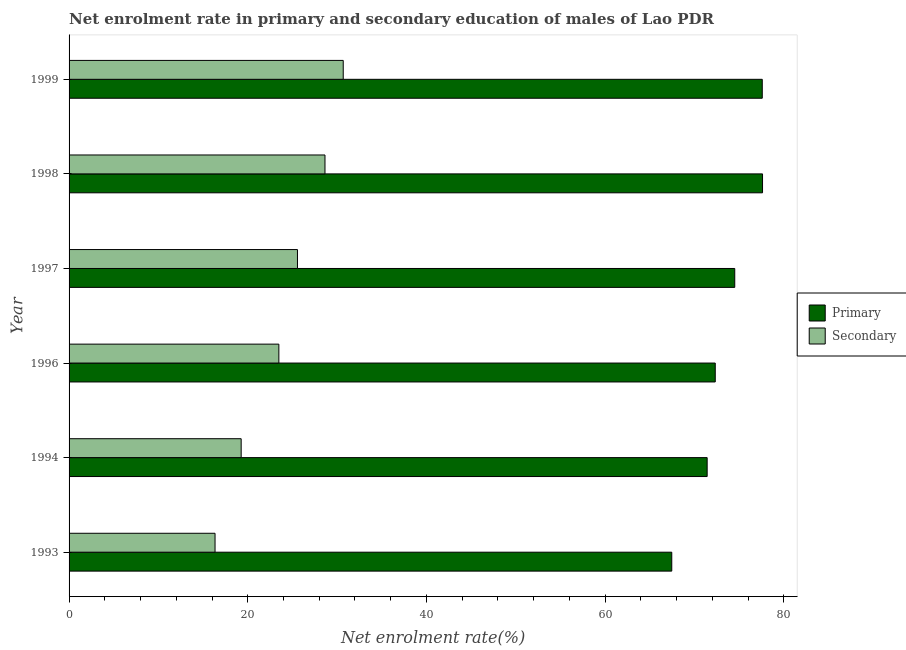Are the number of bars on each tick of the Y-axis equal?
Ensure brevity in your answer.  Yes. How many bars are there on the 3rd tick from the top?
Keep it short and to the point. 2. How many bars are there on the 5th tick from the bottom?
Your response must be concise. 2. What is the label of the 1st group of bars from the top?
Provide a succinct answer. 1999. In how many cases, is the number of bars for a given year not equal to the number of legend labels?
Your response must be concise. 0. What is the enrollment rate in secondary education in 1996?
Make the answer very short. 23.48. Across all years, what is the maximum enrollment rate in secondary education?
Provide a short and direct response. 30.68. Across all years, what is the minimum enrollment rate in primary education?
Keep it short and to the point. 67.45. In which year was the enrollment rate in primary education maximum?
Offer a terse response. 1998. What is the total enrollment rate in primary education in the graph?
Keep it short and to the point. 440.88. What is the difference between the enrollment rate in secondary education in 1998 and that in 1999?
Your response must be concise. -2.04. What is the difference between the enrollment rate in secondary education in 1994 and the enrollment rate in primary education in 1997?
Offer a terse response. -55.24. What is the average enrollment rate in primary education per year?
Your response must be concise. 73.48. In the year 1993, what is the difference between the enrollment rate in secondary education and enrollment rate in primary education?
Your response must be concise. -51.12. In how many years, is the enrollment rate in primary education greater than 52 %?
Provide a short and direct response. 6. What is the ratio of the enrollment rate in secondary education in 1993 to that in 1999?
Make the answer very short. 0.53. Is the enrollment rate in primary education in 1993 less than that in 1998?
Offer a very short reply. Yes. What is the difference between the highest and the second highest enrollment rate in secondary education?
Provide a short and direct response. 2.04. What is the difference between the highest and the lowest enrollment rate in primary education?
Your response must be concise. 10.16. In how many years, is the enrollment rate in secondary education greater than the average enrollment rate in secondary education taken over all years?
Make the answer very short. 3. What does the 1st bar from the top in 1999 represents?
Make the answer very short. Secondary. What does the 2nd bar from the bottom in 1997 represents?
Your answer should be very brief. Secondary. How many years are there in the graph?
Keep it short and to the point. 6. What is the difference between two consecutive major ticks on the X-axis?
Provide a succinct answer. 20. Are the values on the major ticks of X-axis written in scientific E-notation?
Provide a short and direct response. No. Does the graph contain any zero values?
Offer a very short reply. No. Where does the legend appear in the graph?
Provide a succinct answer. Center right. How many legend labels are there?
Your response must be concise. 2. How are the legend labels stacked?
Keep it short and to the point. Vertical. What is the title of the graph?
Offer a terse response. Net enrolment rate in primary and secondary education of males of Lao PDR. What is the label or title of the X-axis?
Your answer should be compact. Net enrolment rate(%). What is the label or title of the Y-axis?
Your answer should be compact. Year. What is the Net enrolment rate(%) of Primary in 1993?
Make the answer very short. 67.45. What is the Net enrolment rate(%) of Secondary in 1993?
Your answer should be very brief. 16.34. What is the Net enrolment rate(%) of Primary in 1994?
Give a very brief answer. 71.41. What is the Net enrolment rate(%) of Secondary in 1994?
Offer a terse response. 19.26. What is the Net enrolment rate(%) of Primary in 1996?
Your answer should be very brief. 72.32. What is the Net enrolment rate(%) in Secondary in 1996?
Provide a short and direct response. 23.48. What is the Net enrolment rate(%) of Primary in 1997?
Keep it short and to the point. 74.5. What is the Net enrolment rate(%) in Secondary in 1997?
Provide a short and direct response. 25.56. What is the Net enrolment rate(%) of Primary in 1998?
Provide a succinct answer. 77.61. What is the Net enrolment rate(%) of Secondary in 1998?
Your answer should be very brief. 28.64. What is the Net enrolment rate(%) in Primary in 1999?
Provide a succinct answer. 77.58. What is the Net enrolment rate(%) of Secondary in 1999?
Offer a very short reply. 30.68. Across all years, what is the maximum Net enrolment rate(%) in Primary?
Make the answer very short. 77.61. Across all years, what is the maximum Net enrolment rate(%) of Secondary?
Offer a very short reply. 30.68. Across all years, what is the minimum Net enrolment rate(%) in Primary?
Give a very brief answer. 67.45. Across all years, what is the minimum Net enrolment rate(%) in Secondary?
Keep it short and to the point. 16.34. What is the total Net enrolment rate(%) of Primary in the graph?
Keep it short and to the point. 440.88. What is the total Net enrolment rate(%) in Secondary in the graph?
Give a very brief answer. 143.97. What is the difference between the Net enrolment rate(%) of Primary in 1993 and that in 1994?
Keep it short and to the point. -3.96. What is the difference between the Net enrolment rate(%) of Secondary in 1993 and that in 1994?
Provide a short and direct response. -2.92. What is the difference between the Net enrolment rate(%) of Primary in 1993 and that in 1996?
Keep it short and to the point. -4.87. What is the difference between the Net enrolment rate(%) in Secondary in 1993 and that in 1996?
Make the answer very short. -7.14. What is the difference between the Net enrolment rate(%) in Primary in 1993 and that in 1997?
Your response must be concise. -7.05. What is the difference between the Net enrolment rate(%) in Secondary in 1993 and that in 1997?
Your response must be concise. -9.22. What is the difference between the Net enrolment rate(%) in Primary in 1993 and that in 1998?
Ensure brevity in your answer.  -10.16. What is the difference between the Net enrolment rate(%) in Secondary in 1993 and that in 1998?
Your answer should be compact. -12.31. What is the difference between the Net enrolment rate(%) of Primary in 1993 and that in 1999?
Ensure brevity in your answer.  -10.13. What is the difference between the Net enrolment rate(%) of Secondary in 1993 and that in 1999?
Offer a terse response. -14.35. What is the difference between the Net enrolment rate(%) in Primary in 1994 and that in 1996?
Make the answer very short. -0.91. What is the difference between the Net enrolment rate(%) in Secondary in 1994 and that in 1996?
Provide a succinct answer. -4.22. What is the difference between the Net enrolment rate(%) in Primary in 1994 and that in 1997?
Provide a succinct answer. -3.09. What is the difference between the Net enrolment rate(%) of Secondary in 1994 and that in 1997?
Your answer should be very brief. -6.3. What is the difference between the Net enrolment rate(%) of Primary in 1994 and that in 1998?
Provide a succinct answer. -6.2. What is the difference between the Net enrolment rate(%) in Secondary in 1994 and that in 1998?
Offer a terse response. -9.38. What is the difference between the Net enrolment rate(%) of Primary in 1994 and that in 1999?
Provide a succinct answer. -6.17. What is the difference between the Net enrolment rate(%) of Secondary in 1994 and that in 1999?
Give a very brief answer. -11.42. What is the difference between the Net enrolment rate(%) in Primary in 1996 and that in 1997?
Your answer should be very brief. -2.18. What is the difference between the Net enrolment rate(%) of Secondary in 1996 and that in 1997?
Keep it short and to the point. -2.08. What is the difference between the Net enrolment rate(%) in Primary in 1996 and that in 1998?
Provide a succinct answer. -5.29. What is the difference between the Net enrolment rate(%) in Secondary in 1996 and that in 1998?
Your answer should be compact. -5.16. What is the difference between the Net enrolment rate(%) in Primary in 1996 and that in 1999?
Your answer should be very brief. -5.26. What is the difference between the Net enrolment rate(%) of Secondary in 1996 and that in 1999?
Offer a terse response. -7.2. What is the difference between the Net enrolment rate(%) of Primary in 1997 and that in 1998?
Give a very brief answer. -3.11. What is the difference between the Net enrolment rate(%) of Secondary in 1997 and that in 1998?
Your answer should be very brief. -3.08. What is the difference between the Net enrolment rate(%) in Primary in 1997 and that in 1999?
Provide a short and direct response. -3.08. What is the difference between the Net enrolment rate(%) of Secondary in 1997 and that in 1999?
Your answer should be compact. -5.12. What is the difference between the Net enrolment rate(%) in Primary in 1998 and that in 1999?
Your response must be concise. 0.03. What is the difference between the Net enrolment rate(%) in Secondary in 1998 and that in 1999?
Your answer should be very brief. -2.04. What is the difference between the Net enrolment rate(%) in Primary in 1993 and the Net enrolment rate(%) in Secondary in 1994?
Provide a short and direct response. 48.19. What is the difference between the Net enrolment rate(%) of Primary in 1993 and the Net enrolment rate(%) of Secondary in 1996?
Provide a short and direct response. 43.97. What is the difference between the Net enrolment rate(%) of Primary in 1993 and the Net enrolment rate(%) of Secondary in 1997?
Your answer should be compact. 41.89. What is the difference between the Net enrolment rate(%) of Primary in 1993 and the Net enrolment rate(%) of Secondary in 1998?
Your response must be concise. 38.81. What is the difference between the Net enrolment rate(%) in Primary in 1993 and the Net enrolment rate(%) in Secondary in 1999?
Keep it short and to the point. 36.77. What is the difference between the Net enrolment rate(%) of Primary in 1994 and the Net enrolment rate(%) of Secondary in 1996?
Keep it short and to the point. 47.93. What is the difference between the Net enrolment rate(%) of Primary in 1994 and the Net enrolment rate(%) of Secondary in 1997?
Make the answer very short. 45.85. What is the difference between the Net enrolment rate(%) of Primary in 1994 and the Net enrolment rate(%) of Secondary in 1998?
Your answer should be very brief. 42.77. What is the difference between the Net enrolment rate(%) in Primary in 1994 and the Net enrolment rate(%) in Secondary in 1999?
Your answer should be very brief. 40.73. What is the difference between the Net enrolment rate(%) of Primary in 1996 and the Net enrolment rate(%) of Secondary in 1997?
Give a very brief answer. 46.76. What is the difference between the Net enrolment rate(%) in Primary in 1996 and the Net enrolment rate(%) in Secondary in 1998?
Make the answer very short. 43.68. What is the difference between the Net enrolment rate(%) in Primary in 1996 and the Net enrolment rate(%) in Secondary in 1999?
Your response must be concise. 41.64. What is the difference between the Net enrolment rate(%) of Primary in 1997 and the Net enrolment rate(%) of Secondary in 1998?
Your answer should be compact. 45.86. What is the difference between the Net enrolment rate(%) in Primary in 1997 and the Net enrolment rate(%) in Secondary in 1999?
Make the answer very short. 43.82. What is the difference between the Net enrolment rate(%) in Primary in 1998 and the Net enrolment rate(%) in Secondary in 1999?
Offer a terse response. 46.93. What is the average Net enrolment rate(%) in Primary per year?
Ensure brevity in your answer.  73.48. What is the average Net enrolment rate(%) of Secondary per year?
Offer a terse response. 23.99. In the year 1993, what is the difference between the Net enrolment rate(%) in Primary and Net enrolment rate(%) in Secondary?
Make the answer very short. 51.12. In the year 1994, what is the difference between the Net enrolment rate(%) of Primary and Net enrolment rate(%) of Secondary?
Give a very brief answer. 52.15. In the year 1996, what is the difference between the Net enrolment rate(%) in Primary and Net enrolment rate(%) in Secondary?
Your answer should be very brief. 48.84. In the year 1997, what is the difference between the Net enrolment rate(%) in Primary and Net enrolment rate(%) in Secondary?
Offer a very short reply. 48.94. In the year 1998, what is the difference between the Net enrolment rate(%) of Primary and Net enrolment rate(%) of Secondary?
Offer a terse response. 48.97. In the year 1999, what is the difference between the Net enrolment rate(%) in Primary and Net enrolment rate(%) in Secondary?
Your answer should be compact. 46.9. What is the ratio of the Net enrolment rate(%) of Primary in 1993 to that in 1994?
Give a very brief answer. 0.94. What is the ratio of the Net enrolment rate(%) of Secondary in 1993 to that in 1994?
Make the answer very short. 0.85. What is the ratio of the Net enrolment rate(%) in Primary in 1993 to that in 1996?
Ensure brevity in your answer.  0.93. What is the ratio of the Net enrolment rate(%) of Secondary in 1993 to that in 1996?
Your response must be concise. 0.7. What is the ratio of the Net enrolment rate(%) of Primary in 1993 to that in 1997?
Make the answer very short. 0.91. What is the ratio of the Net enrolment rate(%) in Secondary in 1993 to that in 1997?
Offer a terse response. 0.64. What is the ratio of the Net enrolment rate(%) of Primary in 1993 to that in 1998?
Your answer should be very brief. 0.87. What is the ratio of the Net enrolment rate(%) in Secondary in 1993 to that in 1998?
Give a very brief answer. 0.57. What is the ratio of the Net enrolment rate(%) of Primary in 1993 to that in 1999?
Your answer should be compact. 0.87. What is the ratio of the Net enrolment rate(%) in Secondary in 1993 to that in 1999?
Your answer should be compact. 0.53. What is the ratio of the Net enrolment rate(%) of Primary in 1994 to that in 1996?
Your response must be concise. 0.99. What is the ratio of the Net enrolment rate(%) of Secondary in 1994 to that in 1996?
Give a very brief answer. 0.82. What is the ratio of the Net enrolment rate(%) in Primary in 1994 to that in 1997?
Provide a succinct answer. 0.96. What is the ratio of the Net enrolment rate(%) of Secondary in 1994 to that in 1997?
Offer a very short reply. 0.75. What is the ratio of the Net enrolment rate(%) in Primary in 1994 to that in 1998?
Make the answer very short. 0.92. What is the ratio of the Net enrolment rate(%) in Secondary in 1994 to that in 1998?
Make the answer very short. 0.67. What is the ratio of the Net enrolment rate(%) in Primary in 1994 to that in 1999?
Make the answer very short. 0.92. What is the ratio of the Net enrolment rate(%) in Secondary in 1994 to that in 1999?
Your answer should be very brief. 0.63. What is the ratio of the Net enrolment rate(%) in Primary in 1996 to that in 1997?
Provide a short and direct response. 0.97. What is the ratio of the Net enrolment rate(%) of Secondary in 1996 to that in 1997?
Your answer should be compact. 0.92. What is the ratio of the Net enrolment rate(%) of Primary in 1996 to that in 1998?
Offer a terse response. 0.93. What is the ratio of the Net enrolment rate(%) in Secondary in 1996 to that in 1998?
Keep it short and to the point. 0.82. What is the ratio of the Net enrolment rate(%) in Primary in 1996 to that in 1999?
Give a very brief answer. 0.93. What is the ratio of the Net enrolment rate(%) in Secondary in 1996 to that in 1999?
Provide a succinct answer. 0.77. What is the ratio of the Net enrolment rate(%) in Primary in 1997 to that in 1998?
Ensure brevity in your answer.  0.96. What is the ratio of the Net enrolment rate(%) in Secondary in 1997 to that in 1998?
Your response must be concise. 0.89. What is the ratio of the Net enrolment rate(%) of Primary in 1997 to that in 1999?
Give a very brief answer. 0.96. What is the ratio of the Net enrolment rate(%) in Secondary in 1997 to that in 1999?
Your answer should be compact. 0.83. What is the ratio of the Net enrolment rate(%) in Secondary in 1998 to that in 1999?
Your answer should be compact. 0.93. What is the difference between the highest and the second highest Net enrolment rate(%) in Primary?
Provide a short and direct response. 0.03. What is the difference between the highest and the second highest Net enrolment rate(%) in Secondary?
Keep it short and to the point. 2.04. What is the difference between the highest and the lowest Net enrolment rate(%) of Primary?
Give a very brief answer. 10.16. What is the difference between the highest and the lowest Net enrolment rate(%) in Secondary?
Offer a terse response. 14.35. 